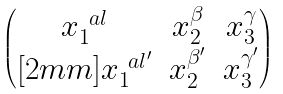<formula> <loc_0><loc_0><loc_500><loc_500>\begin{pmatrix} x _ { 1 } ^ { \ a l } & x _ { 2 } ^ { \beta } & x _ { 3 } ^ { \gamma } \\ [ 2 m m ] x _ { 1 } ^ { \ a l ^ { \prime } } & x _ { 2 } ^ { \beta ^ { \prime } } & x _ { 3 } ^ { \gamma ^ { \prime } } \\ \end{pmatrix}</formula> 